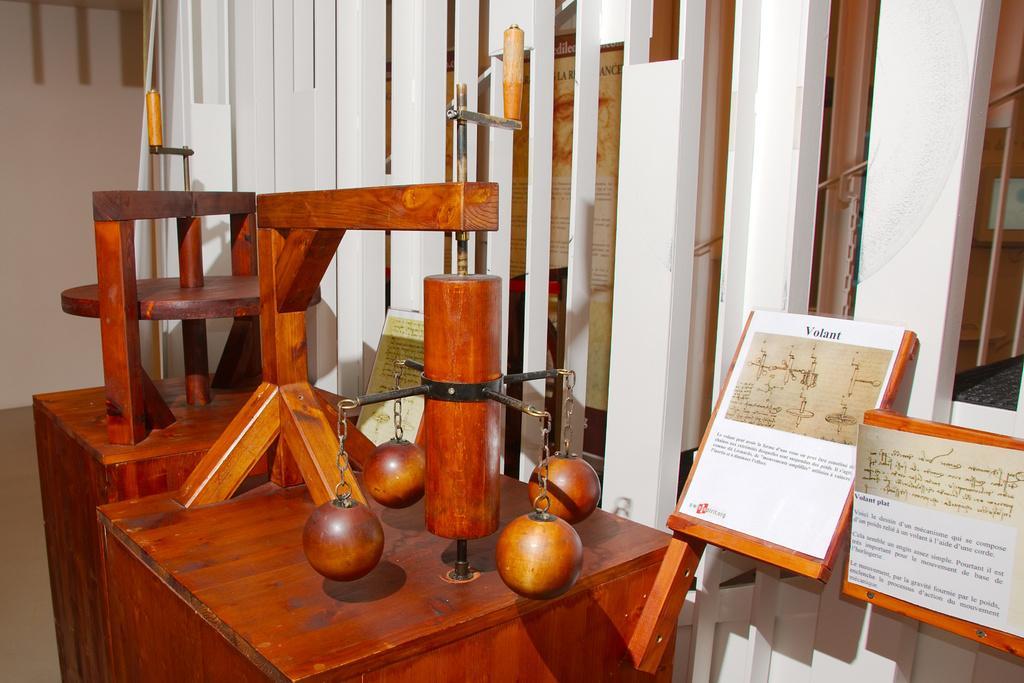In one or two sentences, can you explain what this image depicts? In this picture I can see few brown color things in front and on the right side of this picture I can see 2 boards and I see something is written on it. In the background I can see few white color things. On the left side of this picture I can see the wall. 